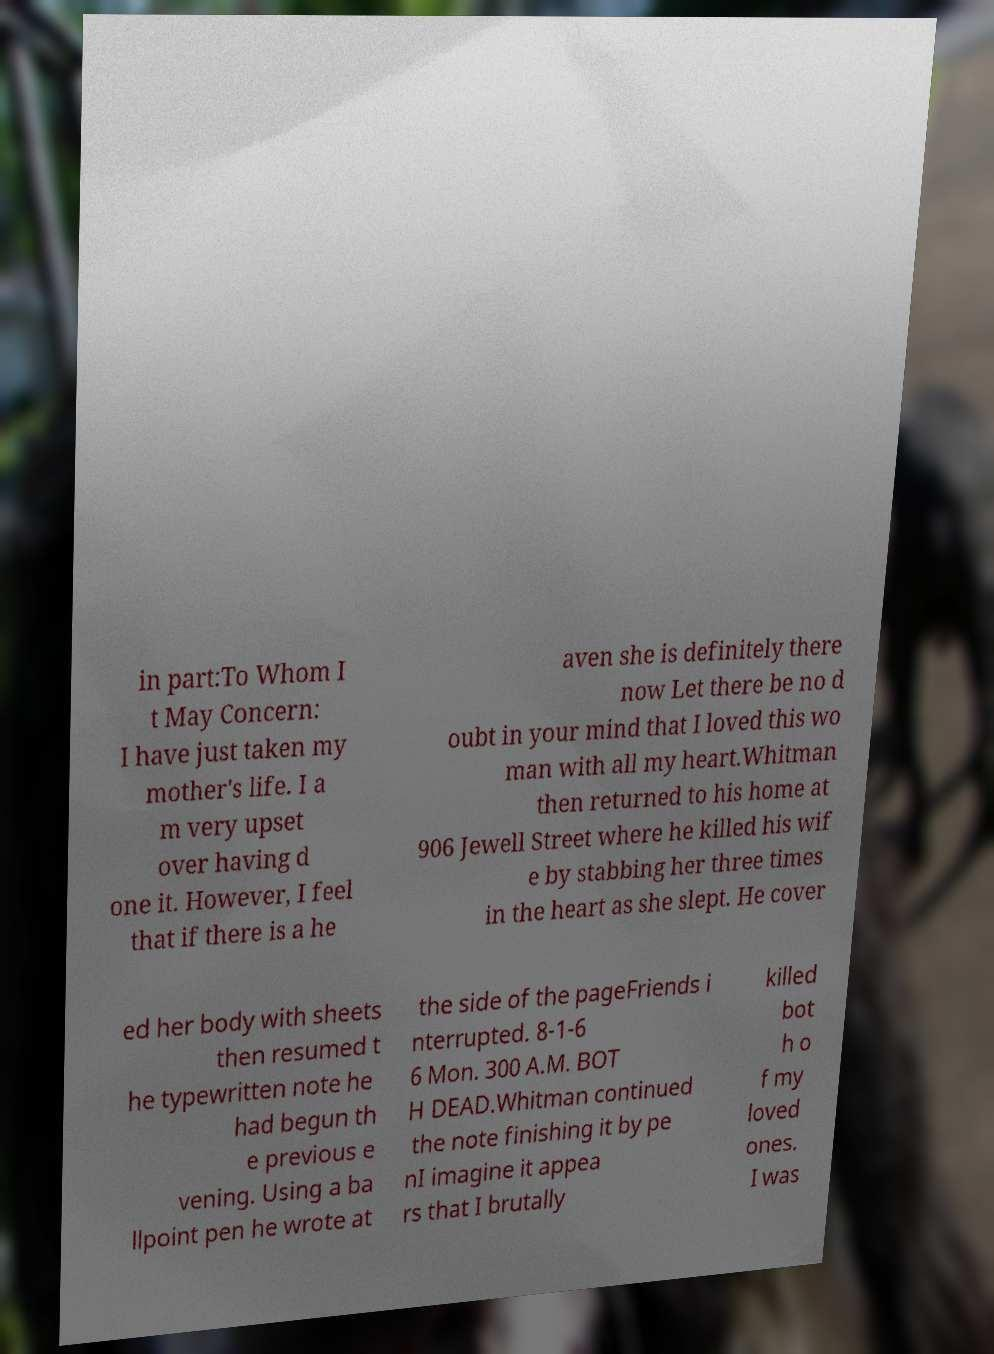What messages or text are displayed in this image? I need them in a readable, typed format. in part:To Whom I t May Concern: I have just taken my mother's life. I a m very upset over having d one it. However, I feel that if there is a he aven she is definitely there now Let there be no d oubt in your mind that I loved this wo man with all my heart.Whitman then returned to his home at 906 Jewell Street where he killed his wif e by stabbing her three times in the heart as she slept. He cover ed her body with sheets then resumed t he typewritten note he had begun th e previous e vening. Using a ba llpoint pen he wrote at the side of the pageFriends i nterrupted. 8-1-6 6 Mon. 300 A.M. BOT H DEAD.Whitman continued the note finishing it by pe nI imagine it appea rs that I brutally killed bot h o f my loved ones. I was 